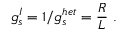<formula> <loc_0><loc_0><loc_500><loc_500>g _ { s } ^ { I } = 1 / g _ { s } ^ { h e t } = { \frac { R } { L } } \ .</formula> 